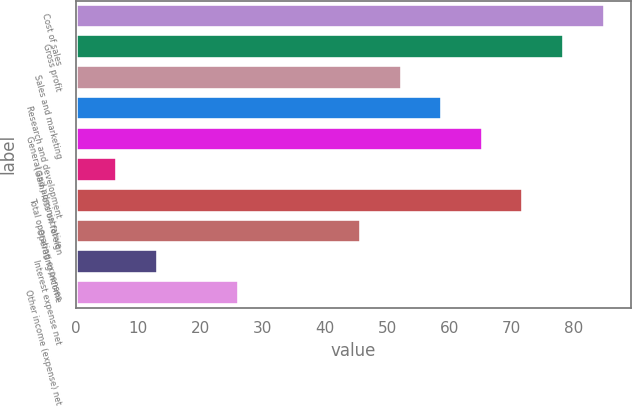<chart> <loc_0><loc_0><loc_500><loc_500><bar_chart><fcel>Cost of sales<fcel>Gross profit<fcel>Sales and marketing<fcel>Research and development<fcel>General and administrative<fcel>(Gain) loss on foreign<fcel>Total operating expenses<fcel>Operating income<fcel>Interest expense net<fcel>Other income (expense) net<nl><fcel>84.99<fcel>78.46<fcel>52.34<fcel>58.87<fcel>65.4<fcel>6.63<fcel>71.93<fcel>45.81<fcel>13.16<fcel>26.22<nl></chart> 